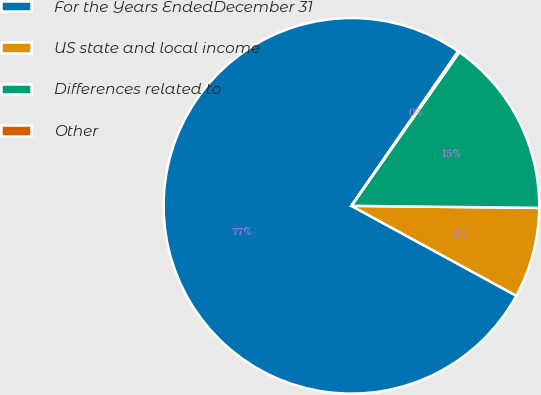<chart> <loc_0><loc_0><loc_500><loc_500><pie_chart><fcel>For the Years EndedDecember 31<fcel>US state and local income<fcel>Differences related to<fcel>Other<nl><fcel>76.68%<fcel>7.77%<fcel>15.43%<fcel>0.12%<nl></chart> 